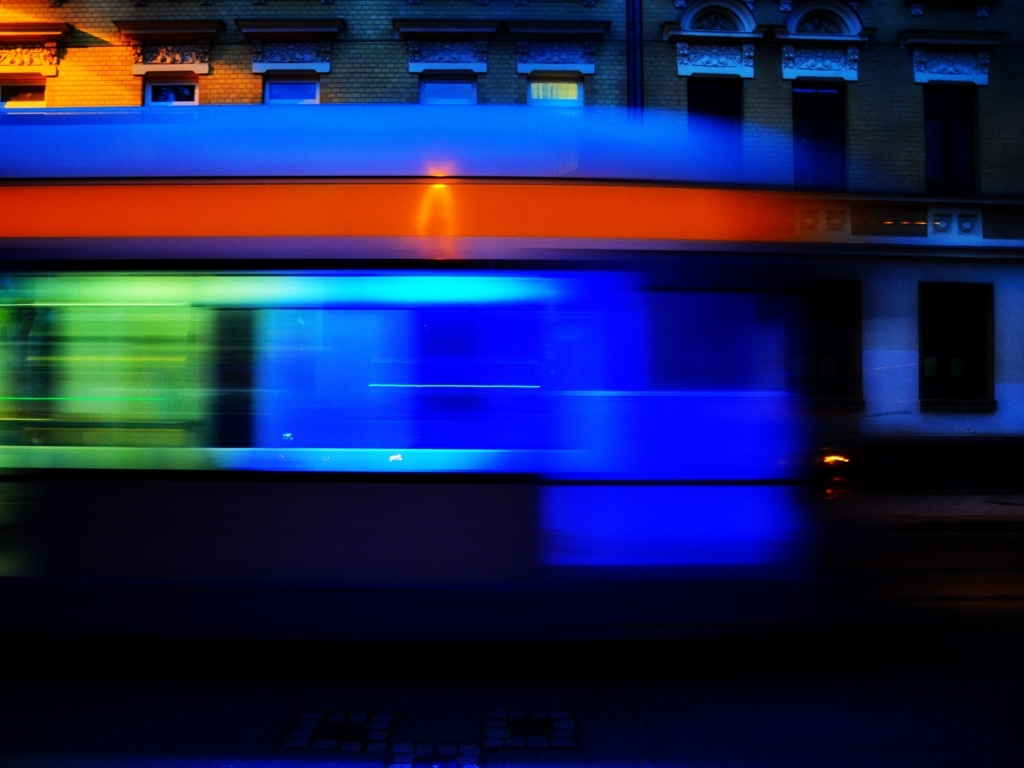What mood does this image convey, and how does it achieve that? The image conveys a sense of dynamic energy and motion, primarily through the use of motion blur. The long exposure time captures the moving bus as a fluid streak of color against the stationary background of the building, which adds contrast and emphasizes the speed of the scene. Why do you think the photographer chose this time of day to take this photo? The photographer likely chose this twilight or nighttime setting to enhance the contrast between the artificial lights of the bus and the ambient darkness. It heightens the vibrancy of moving lights and adds a dramatic effect that wouldn't be present during the daytime. 